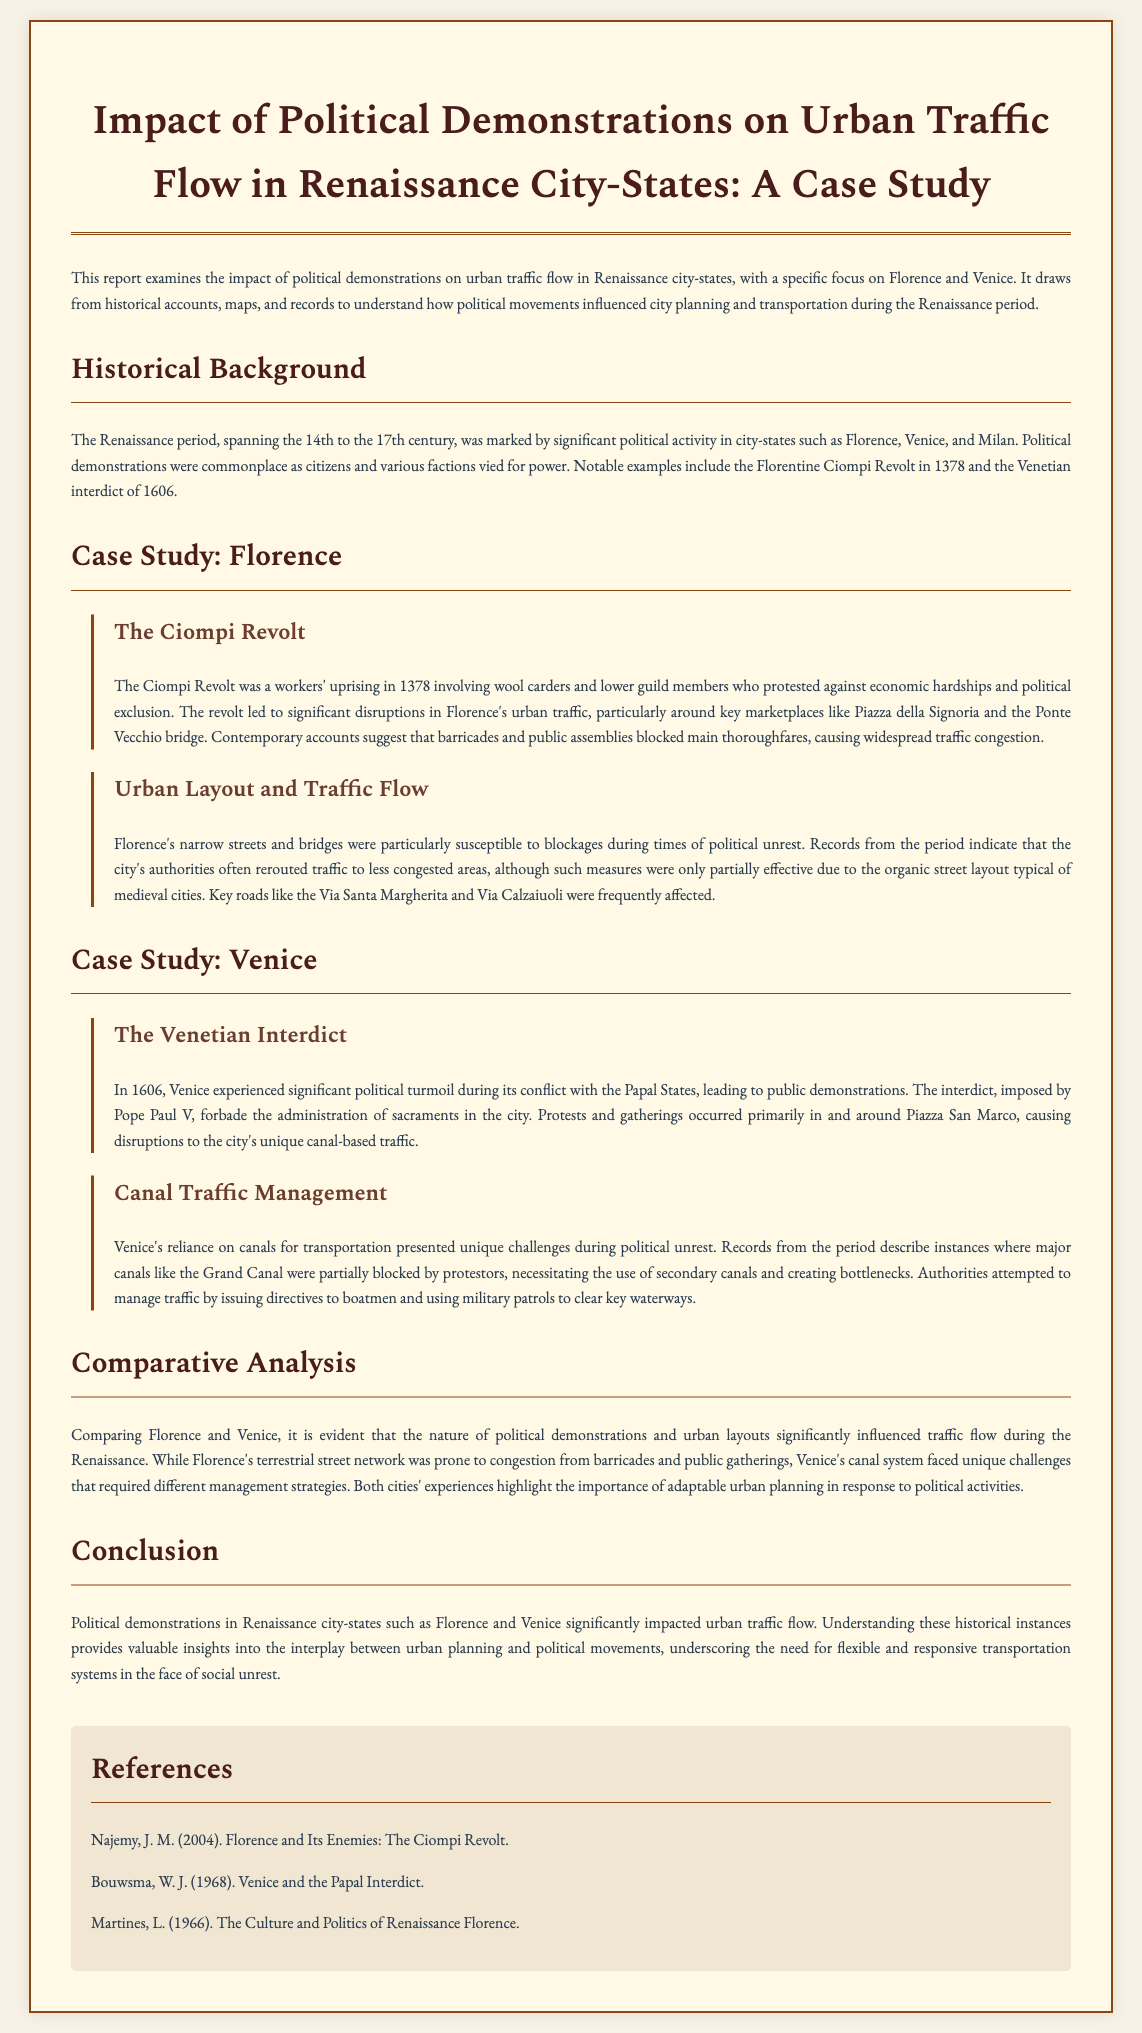what was the duration of the Renaissance period? The Renaissance period spanned from the 14th to the 17th century.
Answer: 14th to 17th century what significant event occurred in Florence in 1378? The significant event in Florence in 1378 was the Ciompi Revolt.
Answer: Ciompi Revolt what is one key location in Florence mentioned in the report? One key location in Florence mentioned in the report is Piazza della Signoria.
Answer: Piazza della Signoria which city's traffic system is primarily canal-based? The city's traffic system primarily based on canals is Venice.
Answer: Venice what were authorities in Venice attempting to manage during political unrest? Authorities in Venice were attempting to manage canal traffic during political unrest.
Answer: canal traffic what strategy did Florence's authorities use during traffic disruptions? Florence's authorities often rerouted traffic to less congested areas during traffic disruptions.
Answer: rerouted traffic how did the urban layouts of Florence and Venice influence traffic flow? The urban layouts of Florence and Venice influenced traffic flow by presenting unique management challenges during demonstrations.
Answer: unique management challenges what was a direct consequence of the Ciompi Revolt in Florence? A direct consequence of the Ciompi Revolt in Florence was significant disruptions in urban traffic.
Answer: significant disruptions who imposed the interdict in Venice in 1606? The interdict in Venice in 1606 was imposed by Pope Paul V.
Answer: Pope Paul V 